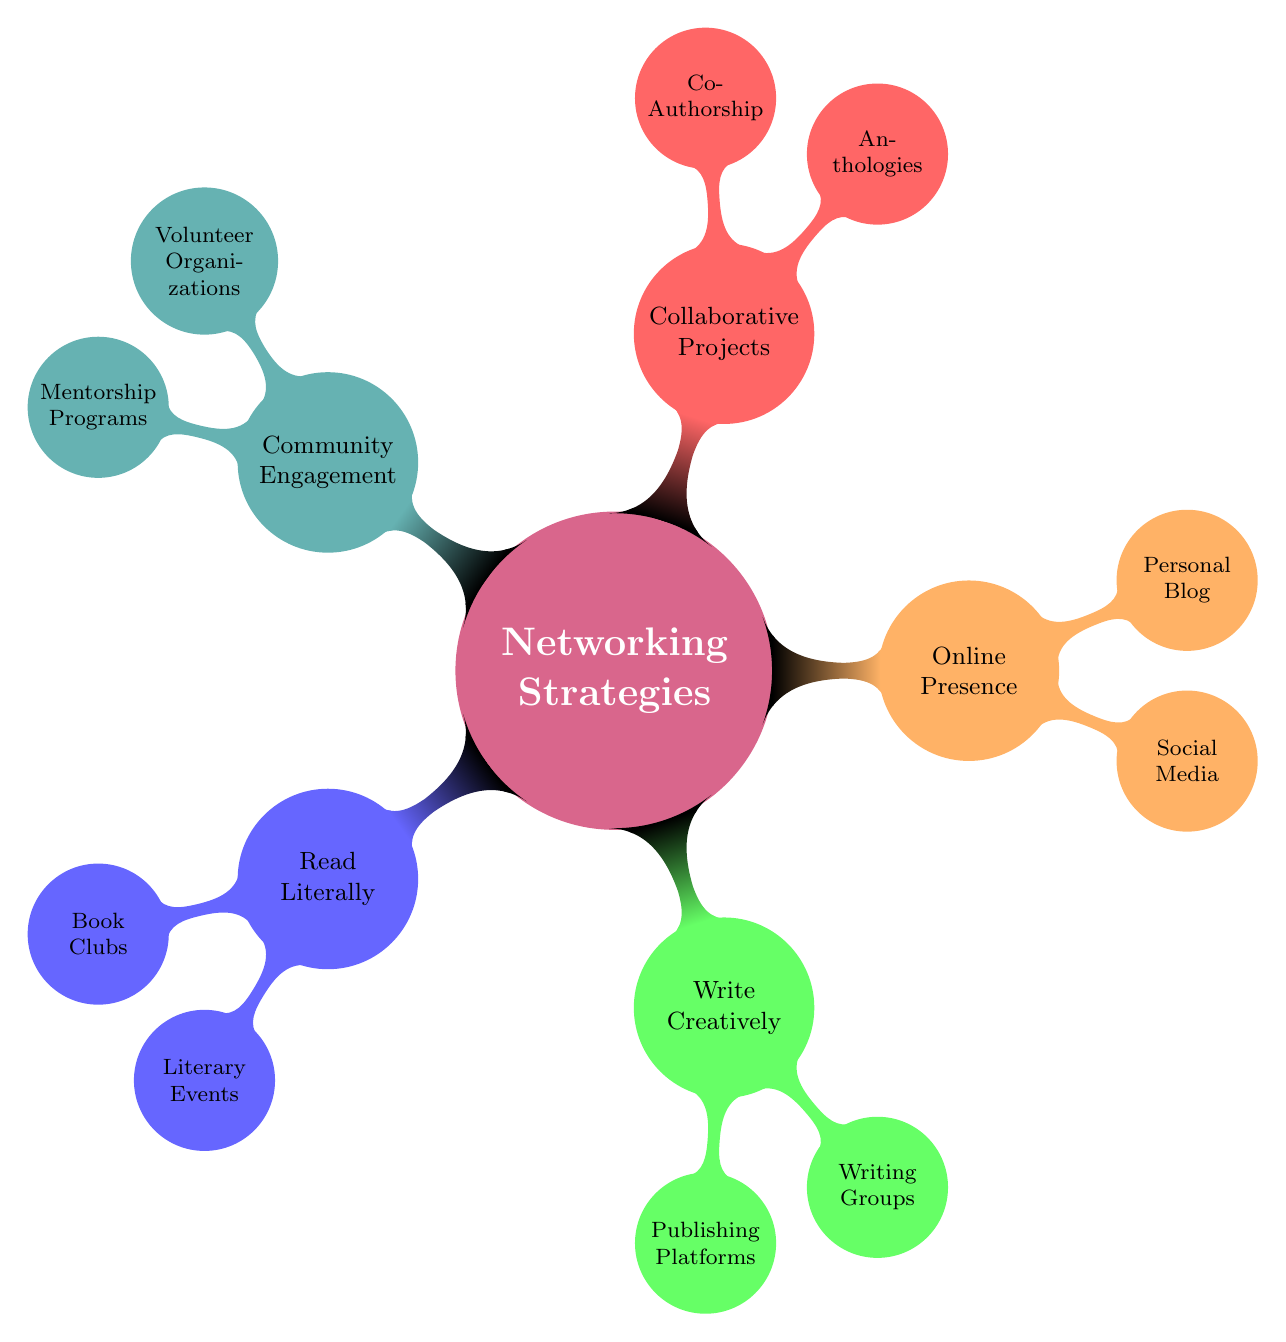What is the main topic of the mind map? The central theme of the mind map is "Networking Strategies," which encompasses various methods and approaches to build connections.
Answer: Networking Strategies How many main strategies are identified in the diagram? The diagram shows five main strategies for networking, which are displayed as first-level nodes branching from the central concept.
Answer: 5 Which subnode falls under "Write Creatively"? The subnodes "Publishing Platforms" and "Writing Groups" are both listed under the "Write Creatively" main strategy as avenues for sharing and developing one's literary work.
Answer: Publishing Platforms, Writing Groups What color represents "Online Presence"? The "Online Presence" node is represented in orange, distinguishing it from other strategies visually within the mind map.
Answer: Orange Which strategy involves collaboration with others? "Collaborative Projects" is the strategy that focuses on working jointly with other writers and enthusiasts, emphasizing teamwork and shared efforts.
Answer: Collaborative Projects Which activity is a way to engage with local literary communities? The "Volunteer Organizations" subnode under "Community Engagement" offers an opportunity for individuals to connect with local literary scenes through volunteer work.
Answer: Volunteer Organizations What are the two subnodes related to "Read Literally"? The subnodes under "Read Literally" are "Book Clubs" and "Literary Events," which focus on participating in reader-oriented gatherings and events.
Answer: Book Clubs, Literary Events Which node mentions the use of social media? The "Social Media" subnode located under "Online Presence" signifies the importance of engaging with audiences through platforms like Twitter, Instagram, and Facebook.
Answer: Social Media How does "Mentorship Programs" fit into the overall theme of the diagram? "Mentorship Programs," as a subnode of "Community Engagement," emphasizes personal development and support, highlighting the importance of guidance in the literary world.
Answer: Community Engagement 